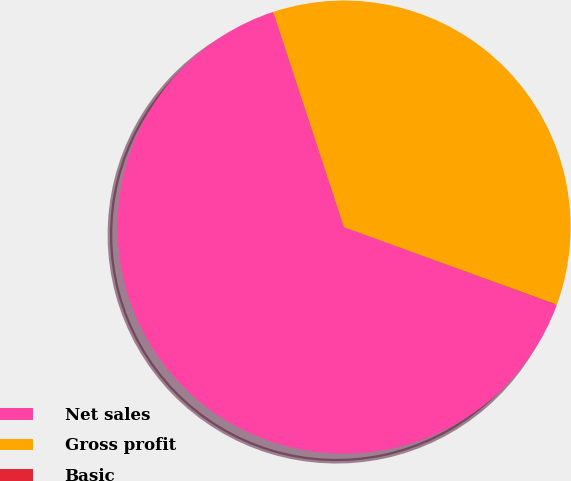Convert chart to OTSL. <chart><loc_0><loc_0><loc_500><loc_500><pie_chart><fcel>Net sales<fcel>Gross profit<fcel>Basic<nl><fcel>64.36%<fcel>35.63%<fcel>0.02%<nl></chart> 